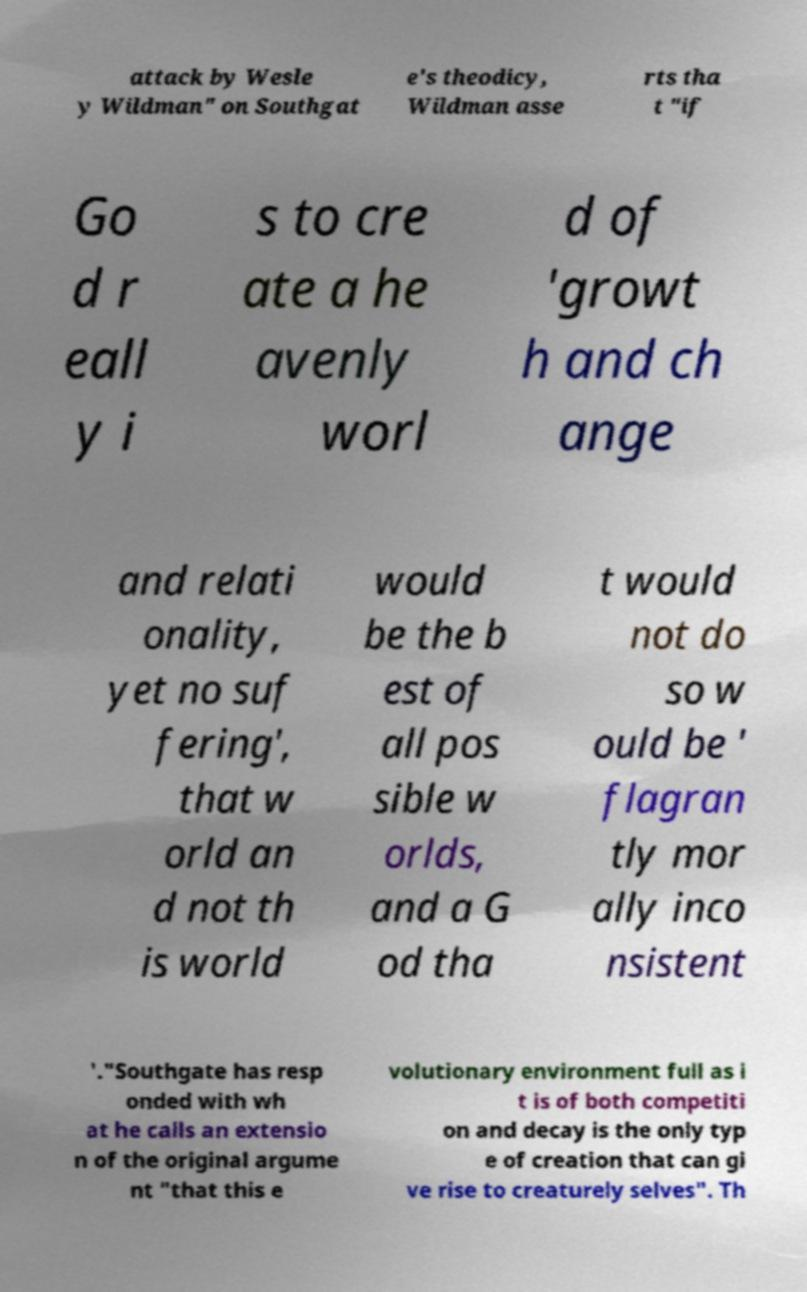For documentation purposes, I need the text within this image transcribed. Could you provide that? attack by Wesle y Wildman" on Southgat e's theodicy, Wildman asse rts tha t "if Go d r eall y i s to cre ate a he avenly worl d of 'growt h and ch ange and relati onality, yet no suf fering', that w orld an d not th is world would be the b est of all pos sible w orlds, and a G od tha t would not do so w ould be ' flagran tly mor ally inco nsistent '."Southgate has resp onded with wh at he calls an extensio n of the original argume nt "that this e volutionary environment full as i t is of both competiti on and decay is the only typ e of creation that can gi ve rise to creaturely selves". Th 